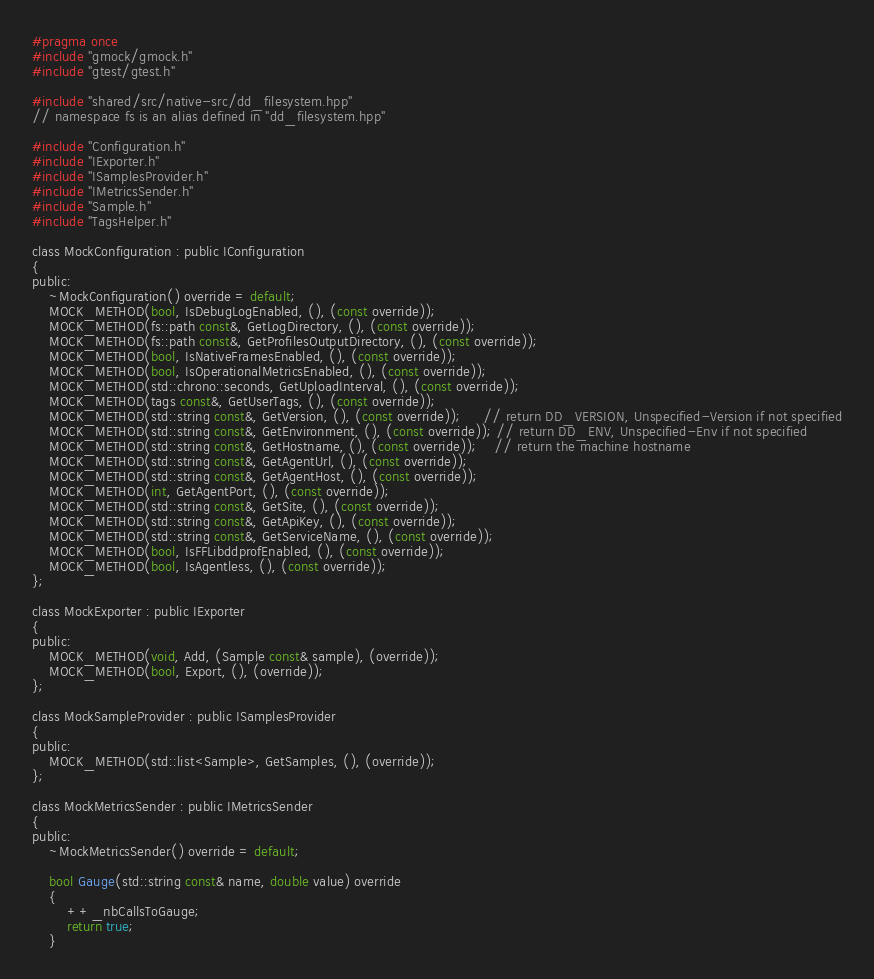<code> <loc_0><loc_0><loc_500><loc_500><_C_>#pragma once
#include "gmock/gmock.h"
#include "gtest/gtest.h"

#include "shared/src/native-src/dd_filesystem.hpp"
// namespace fs is an alias defined in "dd_filesystem.hpp"

#include "Configuration.h"
#include "IExporter.h"
#include "ISamplesProvider.h"
#include "IMetricsSender.h"
#include "Sample.h"
#include "TagsHelper.h"

class MockConfiguration : public IConfiguration
{
public:
    ~MockConfiguration() override = default;
    MOCK_METHOD(bool, IsDebugLogEnabled, (), (const override));
    MOCK_METHOD(fs::path const&, GetLogDirectory, (), (const override));
    MOCK_METHOD(fs::path const&, GetProfilesOutputDirectory, (), (const override));
    MOCK_METHOD(bool, IsNativeFramesEnabled, (), (const override));
    MOCK_METHOD(bool, IsOperationalMetricsEnabled, (), (const override));
    MOCK_METHOD(std::chrono::seconds, GetUploadInterval, (), (const override));
    MOCK_METHOD(tags const&, GetUserTags, (), (const override));
    MOCK_METHOD(std::string const&, GetVersion, (), (const override));     // return DD_VERSION, Unspecified-Version if not specified
    MOCK_METHOD(std::string const&, GetEnvironment, (), (const override)); // return DD_ENV, Unspecified-Env if not specified
    MOCK_METHOD(std::string const&, GetHostname, (), (const override));    // return the machine hostname
    MOCK_METHOD(std::string const&, GetAgentUrl, (), (const override));
    MOCK_METHOD(std::string const&, GetAgentHost, (), (const override));
    MOCK_METHOD(int, GetAgentPort, (), (const override));
    MOCK_METHOD(std::string const&, GetSite, (), (const override));
    MOCK_METHOD(std::string const&, GetApiKey, (), (const override));
    MOCK_METHOD(std::string const&, GetServiceName, (), (const override));
    MOCK_METHOD(bool, IsFFLibddprofEnabled, (), (const override));
    MOCK_METHOD(bool, IsAgentless, (), (const override));
};

class MockExporter : public IExporter
{
public:
    MOCK_METHOD(void, Add, (Sample const& sample), (override));
    MOCK_METHOD(bool, Export, (), (override));
};

class MockSampleProvider : public ISamplesProvider
{
public:
    MOCK_METHOD(std::list<Sample>, GetSamples, (), (override));
};

class MockMetricsSender : public IMetricsSender
{
public:
    ~MockMetricsSender() override = default;

    bool Gauge(std::string const& name, double value) override
    {
        ++_nbCallsToGauge;
        return true;
    }</code> 